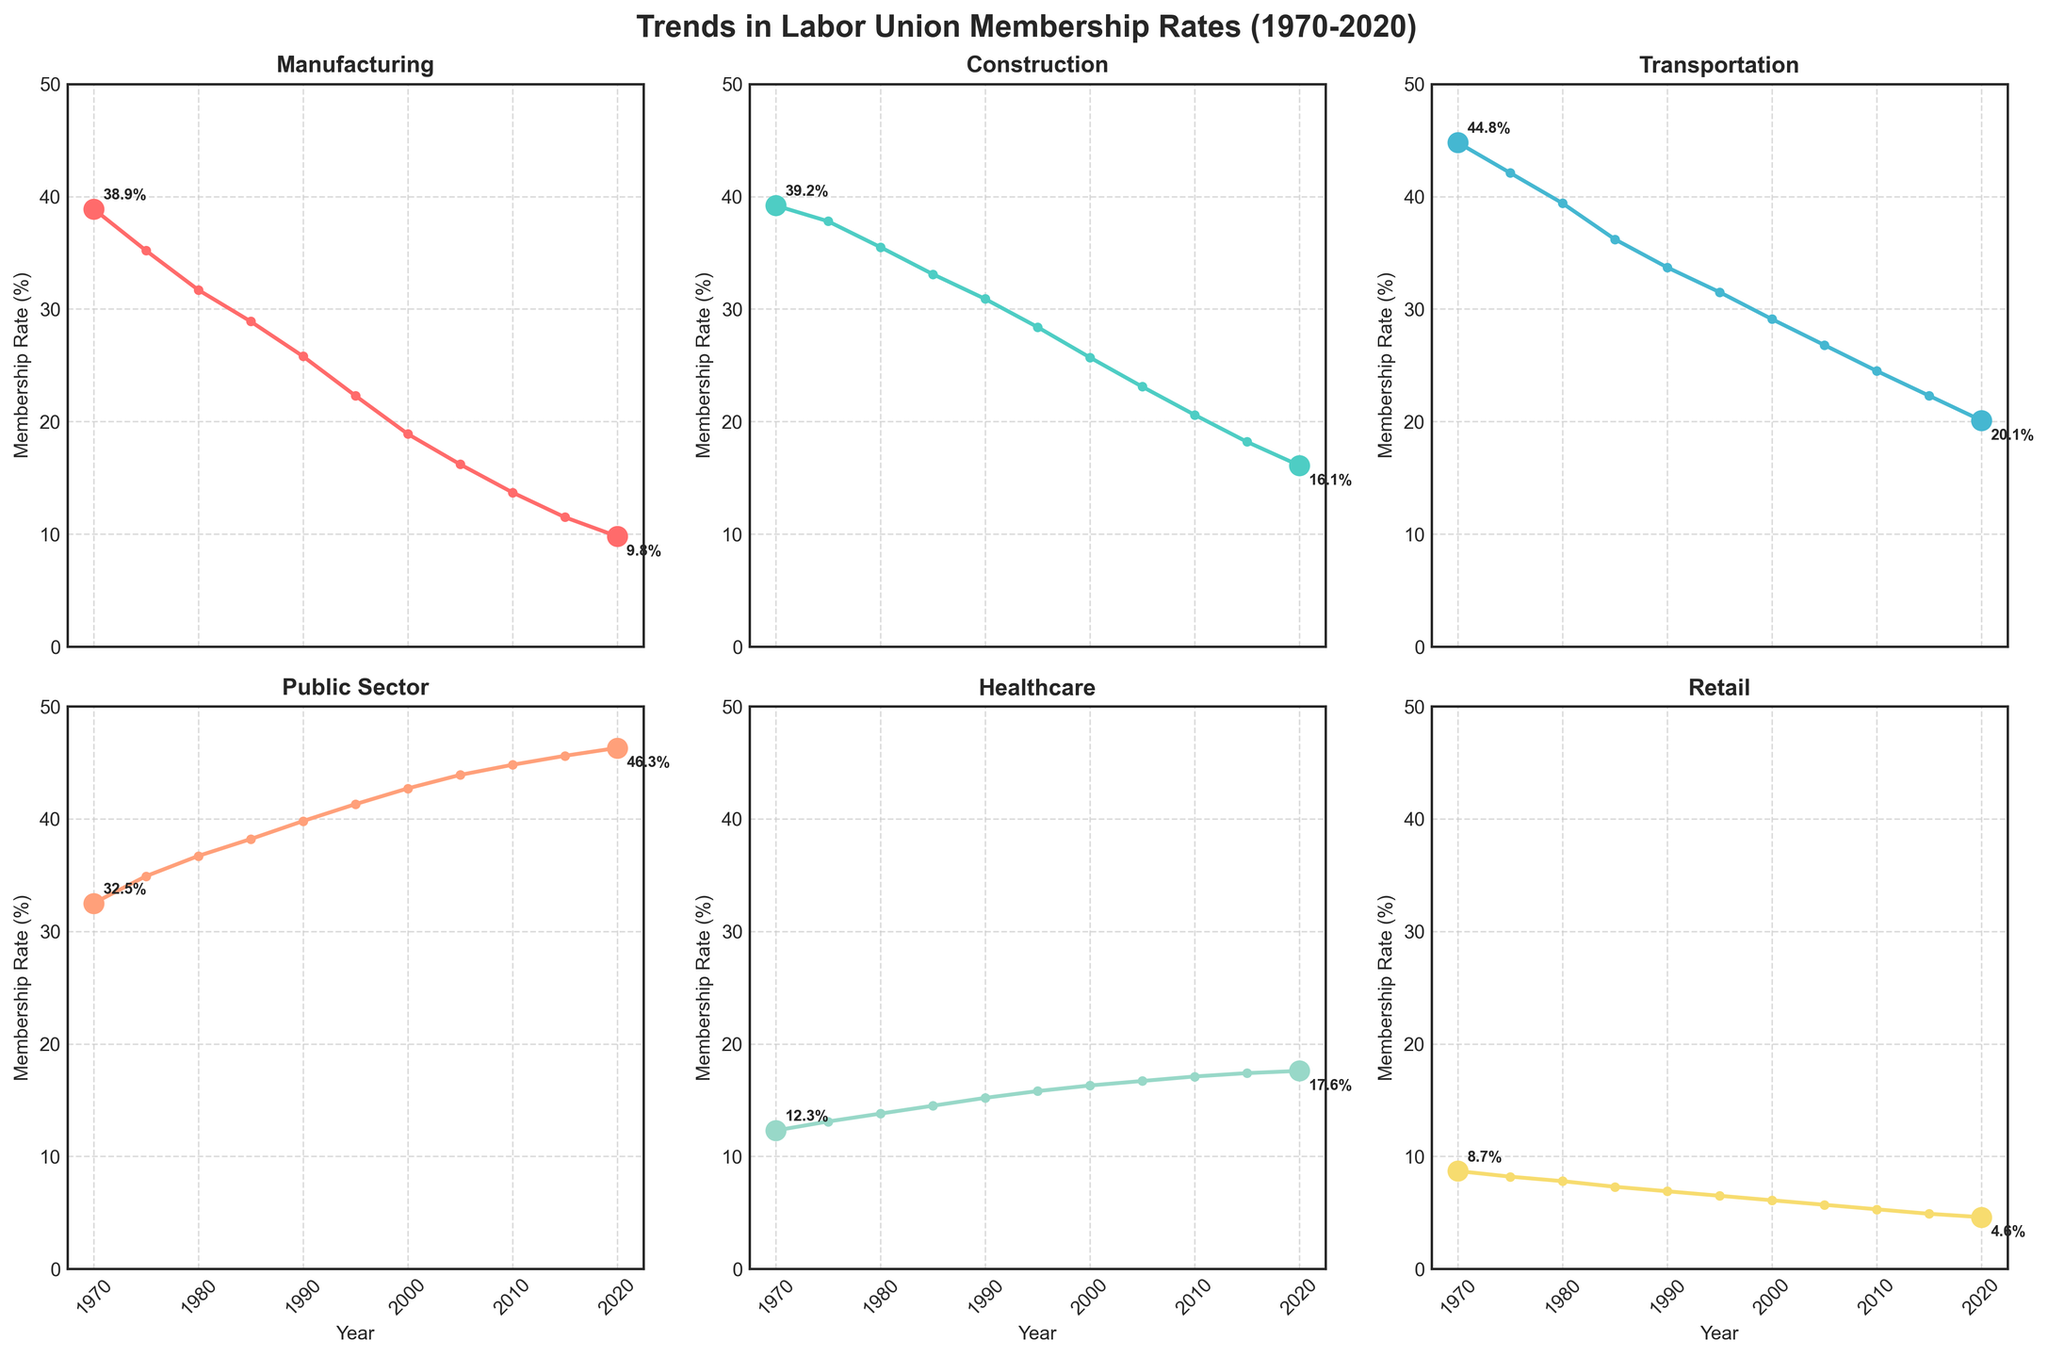Which industry had the highest labor union membership rate in 2020? The figure shows the membership rates of various industries over the years. In 2020, the Public Sector industry has the highest membership rate.
Answer: Public Sector What's the difference in union membership rates for the Construction industry between 1970 and 2020? To find the difference, subtract the membership rate in 2020 from the rate in 1970. From the figure, the Construction industry had a membership rate of 39.2% in 1970 and 16.1% in 2020. The difference is 39.2 - 16.1 = 23.1.
Answer: 23.1% Which industries had an increase in union membership rates from 1975 to 1980? By observing the trends for all industries from 1975 to 1980 on the figure, notice changes in the membership rates. The Healthcare and Public Sector industries showed increases in their rates, while others decreased.
Answer: Healthcare, Public Sector When was the peak of labor union membership rate for the Manufacturing industry? The peak can be identified by observing the line chart for the Manufacturing industry. The highest point for the Manufacturing industry was in 1970, with a membership rate of 38.9%.
Answer: 1970 Which industry shows a relatively stable membership rate line with minimal changes up to 2020? The Public Sector industry line is the most stable, showing gradual changes with minimal fluctuations, unlike the other industries that have steeper declines.
Answer: Public Sector By how much did the membership rate for the Transportation industry drop from 1970 to 2020? Subtract the 2020 rate from the 1970 rate for the Transportation industry. The figure shows 44.8% in 1970 and 20.1% in 2020. The drop is 44.8 - 20.1 = 24.7.
Answer: 24.7% Which industry had the lowest labor union membership rate in 1970? The lowest membership rate in 1970 can be found by comparing all the industry's rates for that year. The Retail industry had the lowest rate at 8.7%.
Answer: Retail In which year did the Retail industry membership rate first fall below 5%? The point at which the Retail industry rate falls below 5% can be seen by examining the plotted line. The rate first fell below 5% in 2015.
Answer: 2015 What is the average union membership rate for the Healthcare industry over the entire period? To find the average, sum the membership rates for all the years and then divide by the number of years. The sum of the Healthcare industry rates from the figure is 12.3 + 13.1 + 13.8 + 14.5 + 15.2 + 15.8 + 16.3 + 16.7 + 17.1 + 17.4 + 17.6 = 169.8. There are 11 years, so the average is 169.8 / 11 ≈ 15.44.
Answer: 15.44% In which two industries did the membership rate lines cross each other between 2000 to 2020? Identifying intersecting lines between 2000 to 2020 reveals that the Construction and Public Sector industry lines crossed.
Answer: Construction, Public Sector 